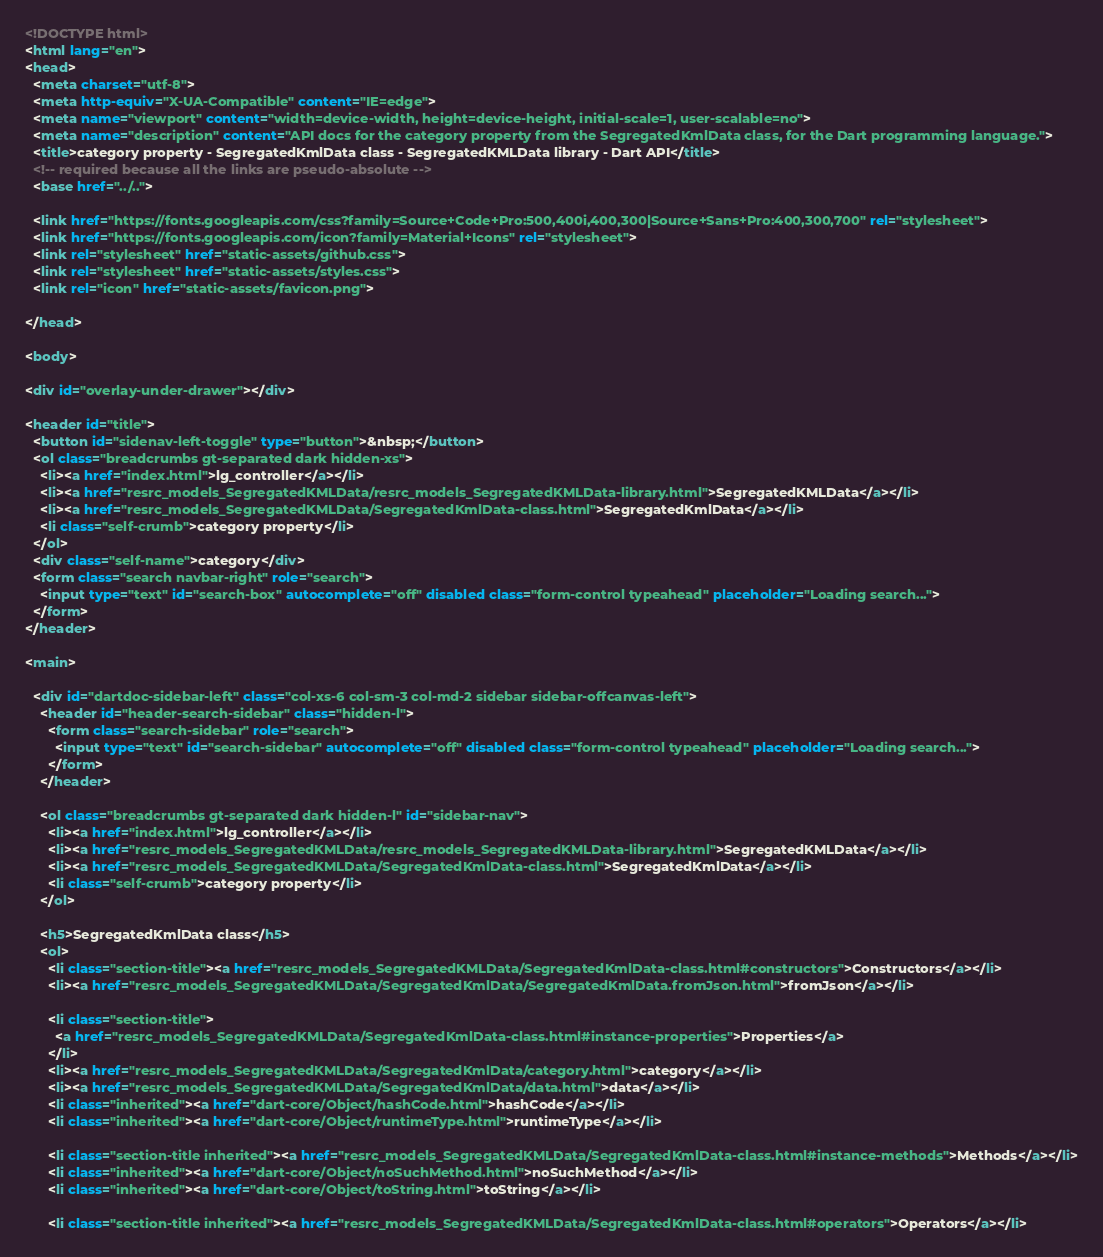<code> <loc_0><loc_0><loc_500><loc_500><_HTML_><!DOCTYPE html>
<html lang="en">
<head>
  <meta charset="utf-8">
  <meta http-equiv="X-UA-Compatible" content="IE=edge">
  <meta name="viewport" content="width=device-width, height=device-height, initial-scale=1, user-scalable=no">
  <meta name="description" content="API docs for the category property from the SegregatedKmlData class, for the Dart programming language.">
  <title>category property - SegregatedKmlData class - SegregatedKMLData library - Dart API</title>
  <!-- required because all the links are pseudo-absolute -->
  <base href="../..">

  <link href="https://fonts.googleapis.com/css?family=Source+Code+Pro:500,400i,400,300|Source+Sans+Pro:400,300,700" rel="stylesheet">
  <link href="https://fonts.googleapis.com/icon?family=Material+Icons" rel="stylesheet">
  <link rel="stylesheet" href="static-assets/github.css">
  <link rel="stylesheet" href="static-assets/styles.css">
  <link rel="icon" href="static-assets/favicon.png">
  
</head>

<body>

<div id="overlay-under-drawer"></div>

<header id="title">
  <button id="sidenav-left-toggle" type="button">&nbsp;</button>
  <ol class="breadcrumbs gt-separated dark hidden-xs">
    <li><a href="index.html">lg_controller</a></li>
    <li><a href="resrc_models_SegregatedKMLData/resrc_models_SegregatedKMLData-library.html">SegregatedKMLData</a></li>
    <li><a href="resrc_models_SegregatedKMLData/SegregatedKmlData-class.html">SegregatedKmlData</a></li>
    <li class="self-crumb">category property</li>
  </ol>
  <div class="self-name">category</div>
  <form class="search navbar-right" role="search">
    <input type="text" id="search-box" autocomplete="off" disabled class="form-control typeahead" placeholder="Loading search...">
  </form>
</header>

<main>

  <div id="dartdoc-sidebar-left" class="col-xs-6 col-sm-3 col-md-2 sidebar sidebar-offcanvas-left">
    <header id="header-search-sidebar" class="hidden-l">
      <form class="search-sidebar" role="search">
        <input type="text" id="search-sidebar" autocomplete="off" disabled class="form-control typeahead" placeholder="Loading search...">
      </form>
    </header>
    
    <ol class="breadcrumbs gt-separated dark hidden-l" id="sidebar-nav">
      <li><a href="index.html">lg_controller</a></li>
      <li><a href="resrc_models_SegregatedKMLData/resrc_models_SegregatedKMLData-library.html">SegregatedKMLData</a></li>
      <li><a href="resrc_models_SegregatedKMLData/SegregatedKmlData-class.html">SegregatedKmlData</a></li>
      <li class="self-crumb">category property</li>
    </ol>
    
    <h5>SegregatedKmlData class</h5>
    <ol>
      <li class="section-title"><a href="resrc_models_SegregatedKMLData/SegregatedKmlData-class.html#constructors">Constructors</a></li>
      <li><a href="resrc_models_SegregatedKMLData/SegregatedKmlData/SegregatedKmlData.fromJson.html">fromJson</a></li>
    
      <li class="section-title">
        <a href="resrc_models_SegregatedKMLData/SegregatedKmlData-class.html#instance-properties">Properties</a>
      </li>
      <li><a href="resrc_models_SegregatedKMLData/SegregatedKmlData/category.html">category</a></li>
      <li><a href="resrc_models_SegregatedKMLData/SegregatedKmlData/data.html">data</a></li>
      <li class="inherited"><a href="dart-core/Object/hashCode.html">hashCode</a></li>
      <li class="inherited"><a href="dart-core/Object/runtimeType.html">runtimeType</a></li>
    
      <li class="section-title inherited"><a href="resrc_models_SegregatedKMLData/SegregatedKmlData-class.html#instance-methods">Methods</a></li>
      <li class="inherited"><a href="dart-core/Object/noSuchMethod.html">noSuchMethod</a></li>
      <li class="inherited"><a href="dart-core/Object/toString.html">toString</a></li>
    
      <li class="section-title inherited"><a href="resrc_models_SegregatedKMLData/SegregatedKmlData-class.html#operators">Operators</a></li></code> 